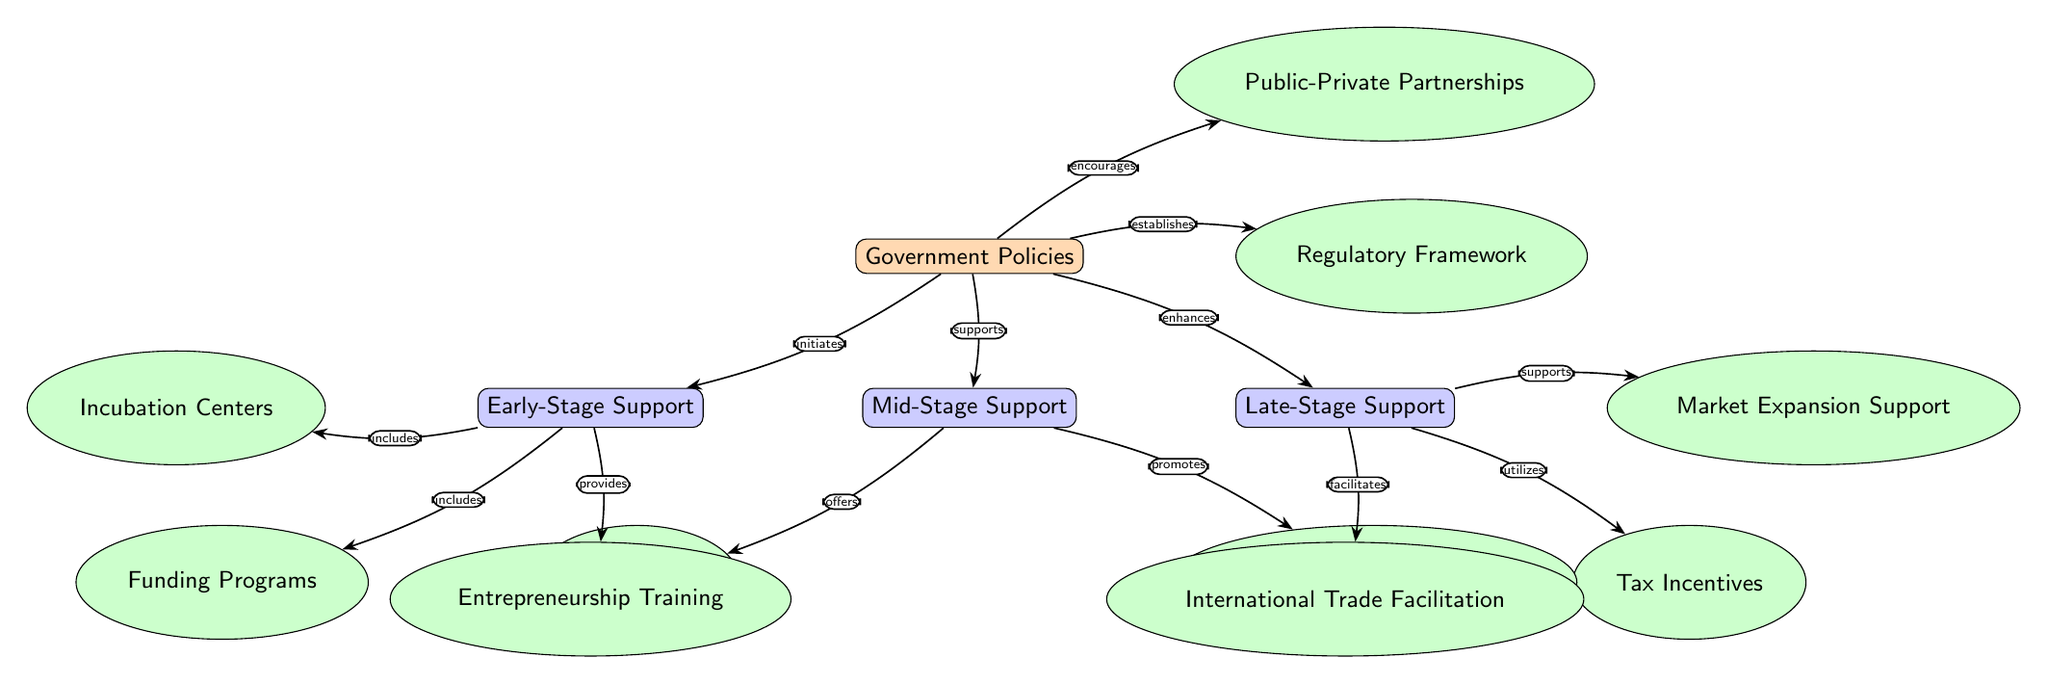What is the primary focus of the network diagram? The diagram illustrates the influence of government policies on various stages of start-up development. Each node represents a distinct aspect or support system involved in this relationship.
Answer: Influence of Government Policies How many total nodes are present in the diagram? After counting each unique node in the diagram, we find a total of 14 nodes representing government policies, stages of support, and specific initiatives.
Answer: 14 What type of support does Early-Stage Support include? The diagram indicates that Early-Stage Support includes both Funding Programs and Incubation Centers, as represented by the connecting edges labeled "includes."
Answer: Funding Programs, Incubation Centers Which node does the Government Policies node directly enhance? Tracing the edges connected to the Government Policies node, we see that it directly enhances Late-Stage Support, as labeled by the edge relationship "enhances."
Answer: Late-Stage Support What is the relationship between Mid-Stage Support and Venture Capital Incentives? According to the diagram, the relationship is one of promotion, where Mid-Stage Support promotes Venture Capital Incentives, as indicated by the edge labeled "promotes."
Answer: promotes Which node is established by Government Policies? The diagram shows that Government Policies establishes a Regulatory Framework, as indicated by the edge relationship labeled "establishes."
Answer: Regulatory Framework How many edges are connecting to the Late-Stage Support node? By counting the edges leading to the Late-Stage Support node, there are three connections: one to Tax Incentives, one to Market Expansion Support, and one to International Trade Facilitation.
Answer: 3 What does the connection from Government Policies to Entrepreneurship Training signify? The connection signifies that Government Policies provides support for Entrepreneurship Training, as reflected by the labeled edge "provides."
Answer: provides What form of support does the Late-Stage Support provide towards International Trade? The diagram illustrates that Late-Stage Support facilitates International Trade Facilitation as indicated by the labeled edge "facilitates."
Answer: facilitates 